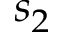<formula> <loc_0><loc_0><loc_500><loc_500>s _ { 2 }</formula> 